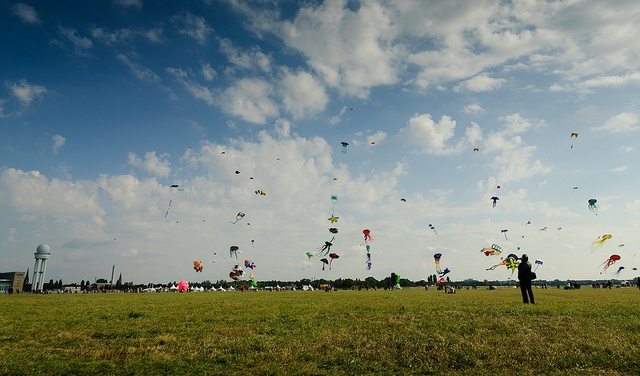Describe the objects in this image and their specific colors. I can see kite in navy, black, darkgray, olive, and lightgray tones, people in navy, black, lightgray, darkgreen, and gray tones, kite in navy, black, darkgreen, olive, and gray tones, kite in navy, beige, lightgray, maroon, and brown tones, and kite in navy, beige, lightgray, olive, and tan tones in this image. 